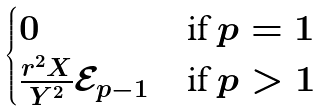<formula> <loc_0><loc_0><loc_500><loc_500>\begin{cases} 0 & \text {if $p=1$} \\ \frac { r ^ { 2 } X } { Y ^ { 2 } } { \mathcal { E } } _ { p - 1 } & \text {if $p>1$} \end{cases}</formula> 